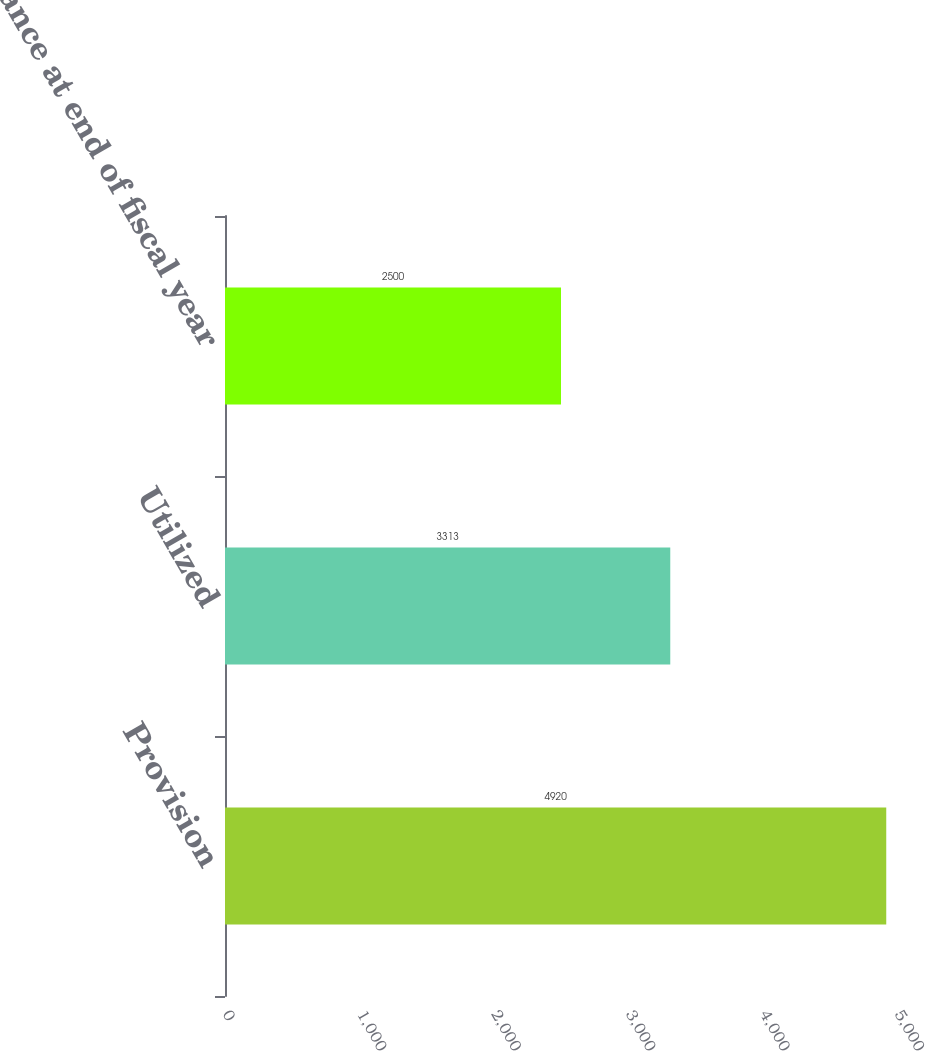Convert chart. <chart><loc_0><loc_0><loc_500><loc_500><bar_chart><fcel>Provision<fcel>Utilized<fcel>Balance at end of fiscal year<nl><fcel>4920<fcel>3313<fcel>2500<nl></chart> 